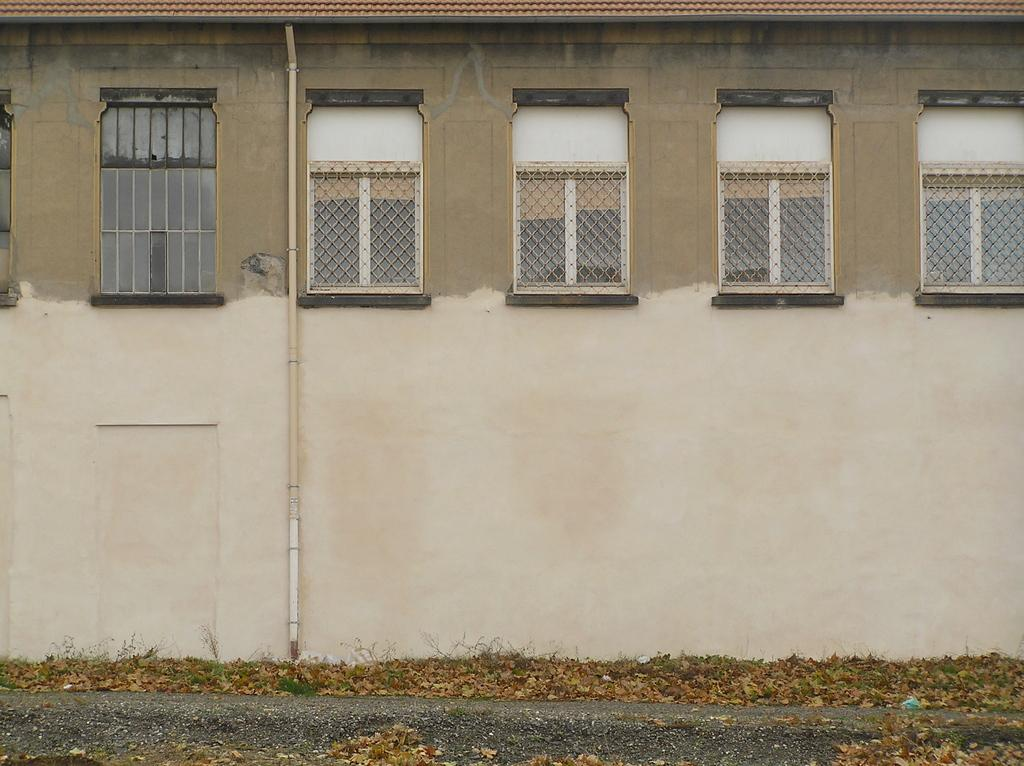What type of structure is visible in the image? There is a building in the image. What is the color of the building? The building is in a cream color. What type of material is used for the windows on the building? There are glass windows on the building. Is there any additional feature attached to the building? Yes, there is a pipe attached to the building. How many times does the toad fold its legs in the image? There is no toad present in the image, so this question cannot be answered. 